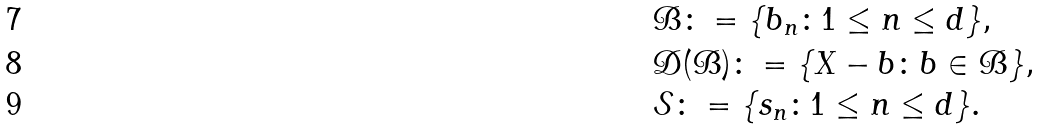<formula> <loc_0><loc_0><loc_500><loc_500>& \mathcal { B } \colon = \{ b _ { n } \colon 1 \leq n \leq d \} , \\ & \mathcal { D } ( \mathcal { B } ) \colon = \{ X - b \colon b \in \mathcal { B } \} , \\ & \mathcal { S } \colon = \{ s _ { n } \colon 1 \leq n \leq d \} .</formula> 